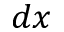<formula> <loc_0><loc_0><loc_500><loc_500>d x</formula> 